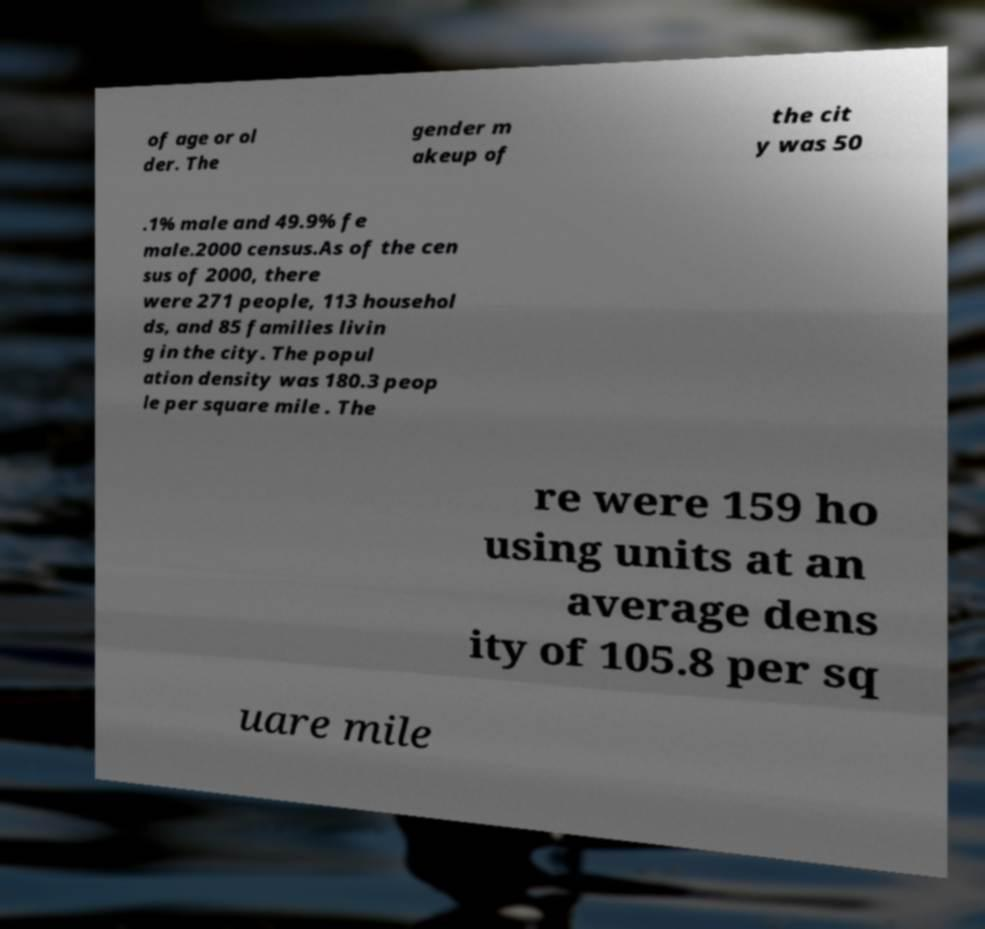For documentation purposes, I need the text within this image transcribed. Could you provide that? of age or ol der. The gender m akeup of the cit y was 50 .1% male and 49.9% fe male.2000 census.As of the cen sus of 2000, there were 271 people, 113 househol ds, and 85 families livin g in the city. The popul ation density was 180.3 peop le per square mile . The re were 159 ho using units at an average dens ity of 105.8 per sq uare mile 